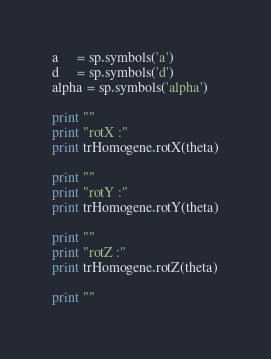Convert code to text. <code><loc_0><loc_0><loc_500><loc_500><_Python_>a     = sp.symbols('a')
d     = sp.symbols('d')
alpha = sp.symbols('alpha')

print ""
print "rotX :"
print trHomogene.rotX(theta)

print ""
print "rotY :"
print trHomogene.rotY(theta)

print ""
print "rotZ :"
print trHomogene.rotZ(theta)

print ""</code> 